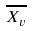Convert formula to latex. <formula><loc_0><loc_0><loc_500><loc_500>\overline { X _ { v } }</formula> 